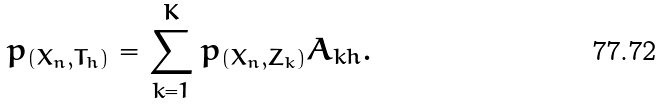Convert formula to latex. <formula><loc_0><loc_0><loc_500><loc_500>p _ { ( X _ { n } , T _ { h } ) } = \sum _ { k = 1 } ^ { K } p _ { ( X _ { n } , Z _ { k } ) } A _ { k h } .</formula> 